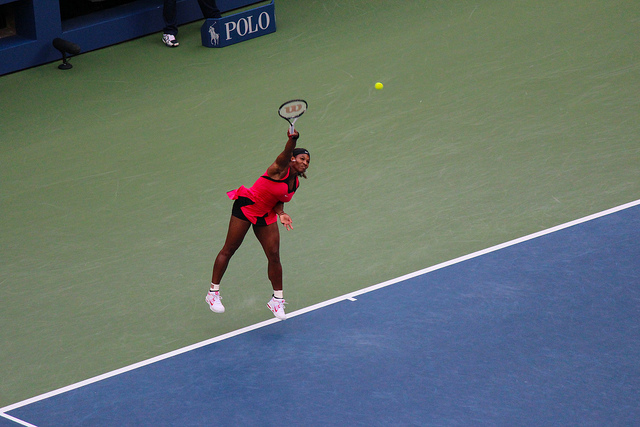Identify the text displayed in this image. W POLO 